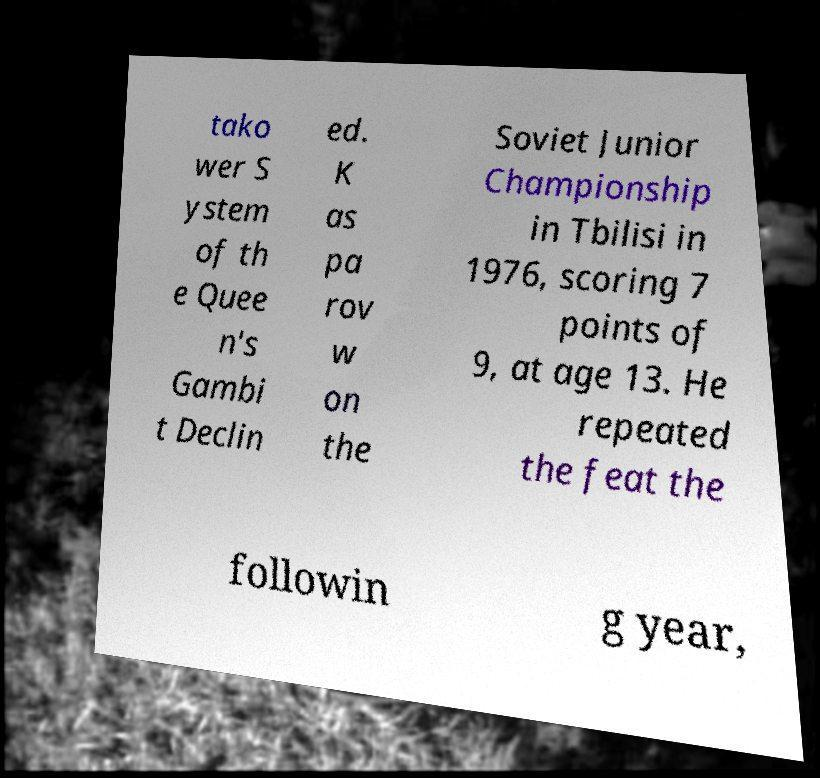Please read and relay the text visible in this image. What does it say? tako wer S ystem of th e Quee n's Gambi t Declin ed. K as pa rov w on the Soviet Junior Championship in Tbilisi in 1976, scoring 7 points of 9, at age 13. He repeated the feat the followin g year, 